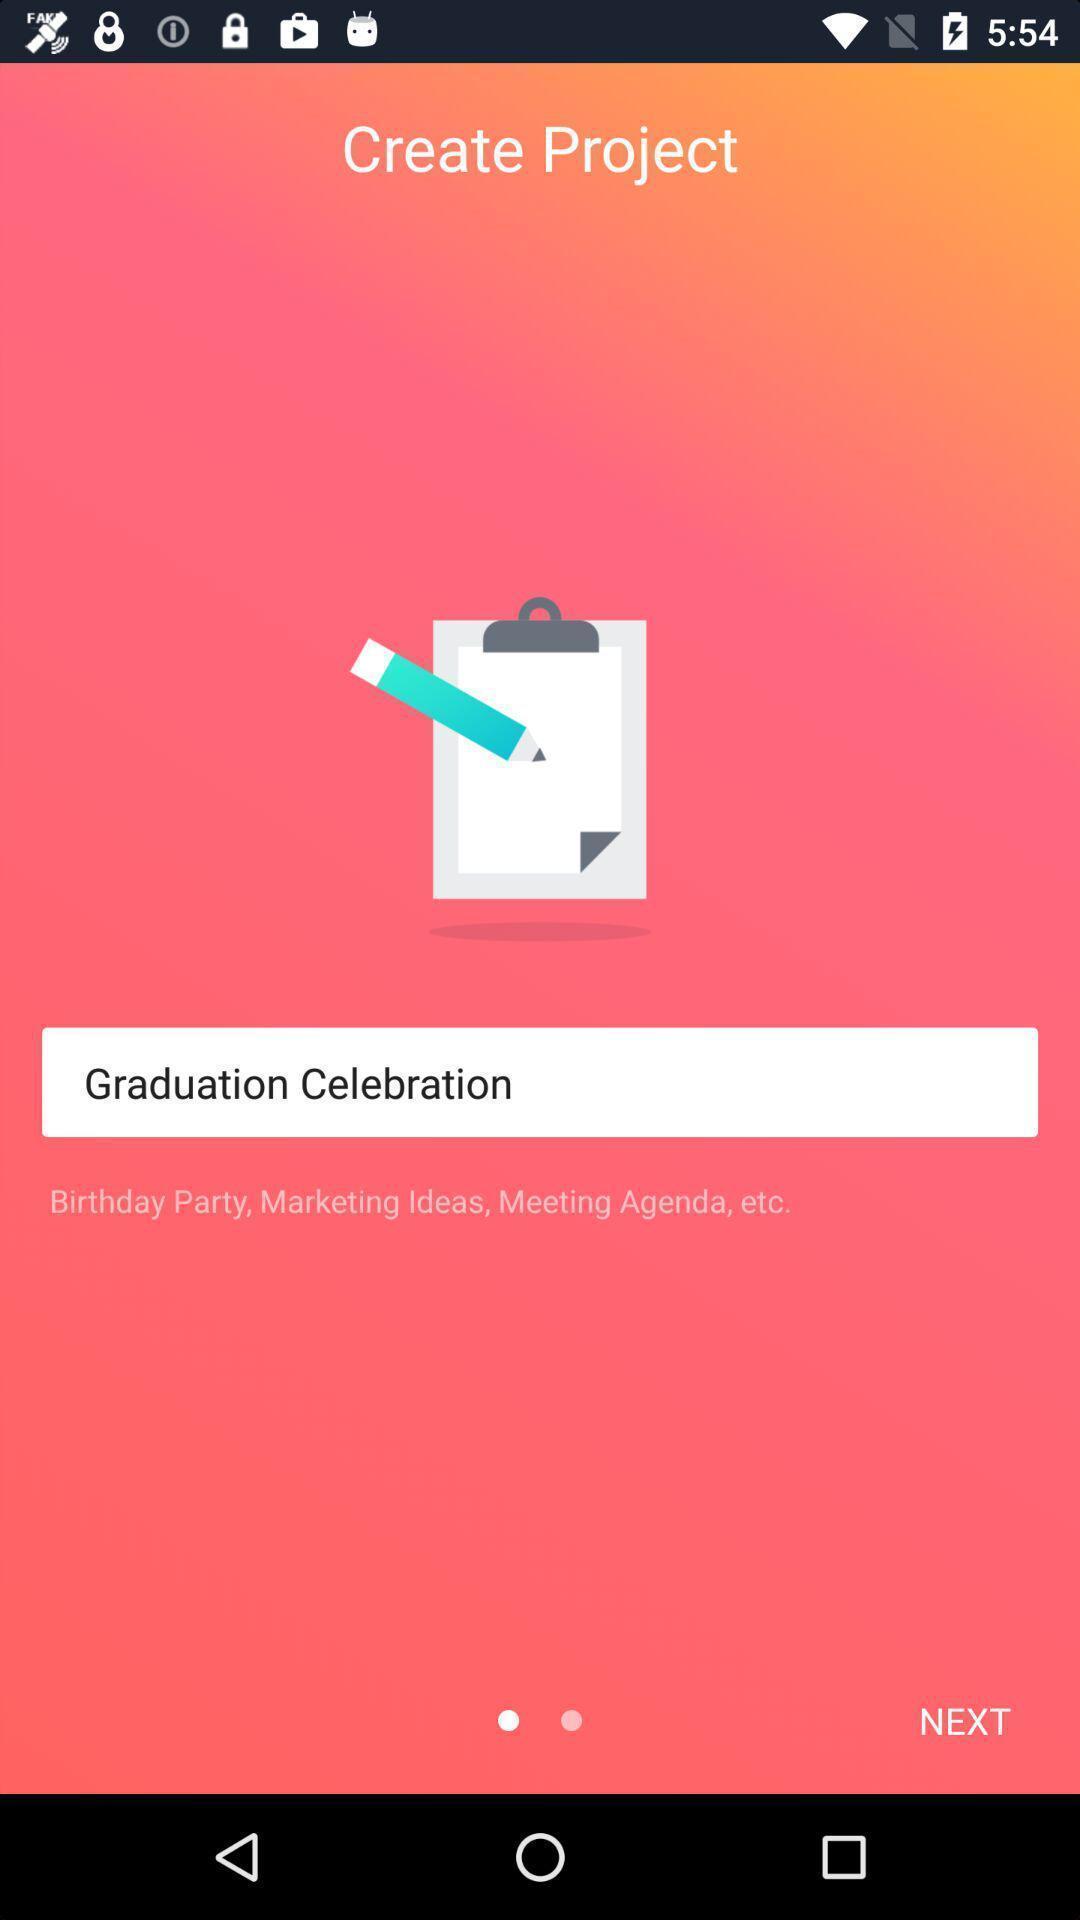Tell me what you see in this picture. Page showing information from a project page. 